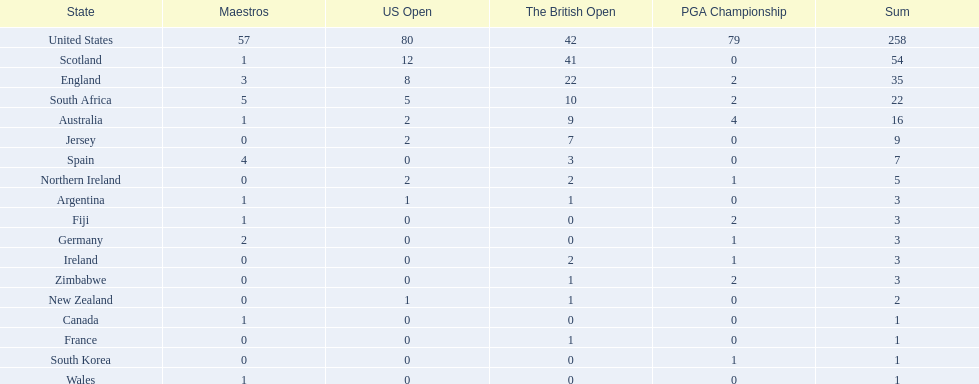What are all the countries? United States, Scotland, England, South Africa, Australia, Jersey, Spain, Northern Ireland, Argentina, Fiji, Germany, Ireland, Zimbabwe, New Zealand, Canada, France, South Korea, Wales. Which ones are located in africa? South Africa, Zimbabwe. Of those, which has the least champion golfers? Zimbabwe. 